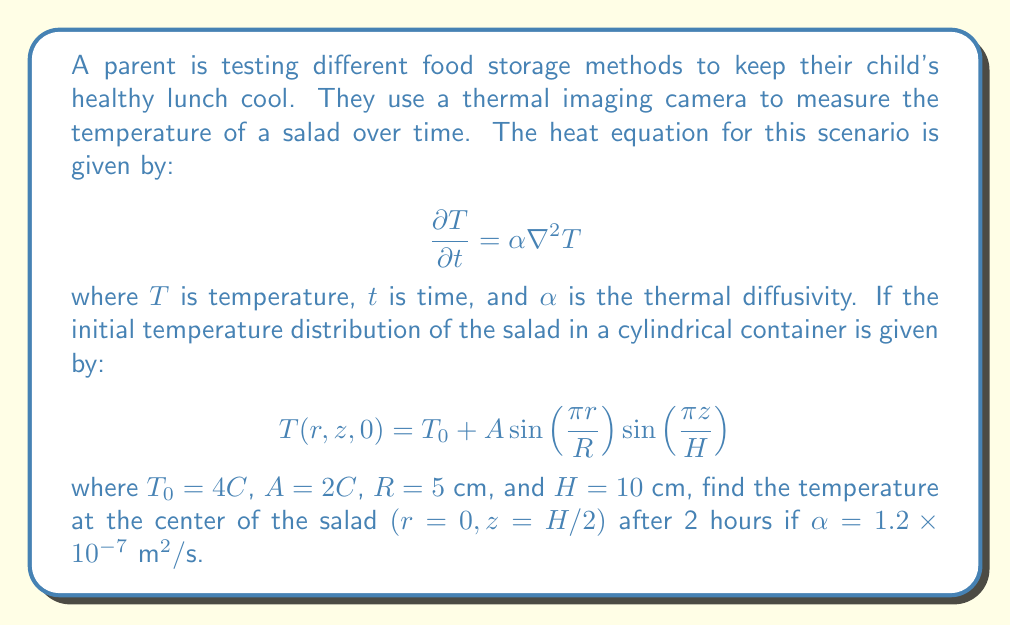Show me your answer to this math problem. To solve this problem, we'll follow these steps:

1) The general solution to the heat equation in cylindrical coordinates is:

   $$T(r,z,t) = T_0 + \sum_{m=1}^{\infty}\sum_{n=1}^{\infty} A_{mn} J_0(\lambda_m r) \sin(\frac{n\pi z}{H}) e^{-\alpha(\lambda_m^2 + (\frac{n\pi}{H})^2)t}$$

   where $J_0$ is the Bessel function of the first kind of order zero, and $\lambda_m$ are the roots of $J_0(\lambda_m R) = 0$.

2) Comparing our initial condition with this general solution, we can see that only the first term $(m=1, n=1)$ is non-zero, and $\lambda_1 = \frac{\pi}{R}$.

3) Therefore, our solution simplifies to:

   $$T(r,z,t) = T_0 + A J_0(\frac{\pi r}{R}) \sin(\frac{\pi z}{H}) e^{-\alpha((\frac{\pi}{R})^2 + (\frac{\pi}{H})^2)t}$$

4) At the center of the salad, $r=0$ and $z=H/2$. Note that $J_0(0) = 1$.

5) Substituting these values and the given constants:

   $$T(0,H/2,t) = 4 + 2 \cdot 1 \cdot \sin(\frac{\pi}{2}) e^{-1.2 \times 10^{-7}((\frac{\pi}{0.05})^2 + (\frac{\pi}{0.1})^2)t}$$

6) Simplify:

   $$T(0,H/2,t) = 4 + 2 e^{-1.2 \times 10^{-7}(3948.41)t}$$

7) For $t = 2$ hours = 7200 seconds:

   $$T(0,H/2,7200) = 4 + 2 e^{-3.4074}$$

8) Calculate the final result:

   $$T(0,H/2,7200) = 4 + 2(0.0331) = 4.0662°C$$
Answer: $4.07°C$ 